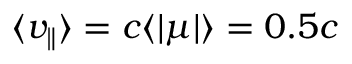Convert formula to latex. <formula><loc_0><loc_0><loc_500><loc_500>\langle { v _ { \| } } \rangle = c \langle | \mu | \rangle = 0 . 5 c</formula> 